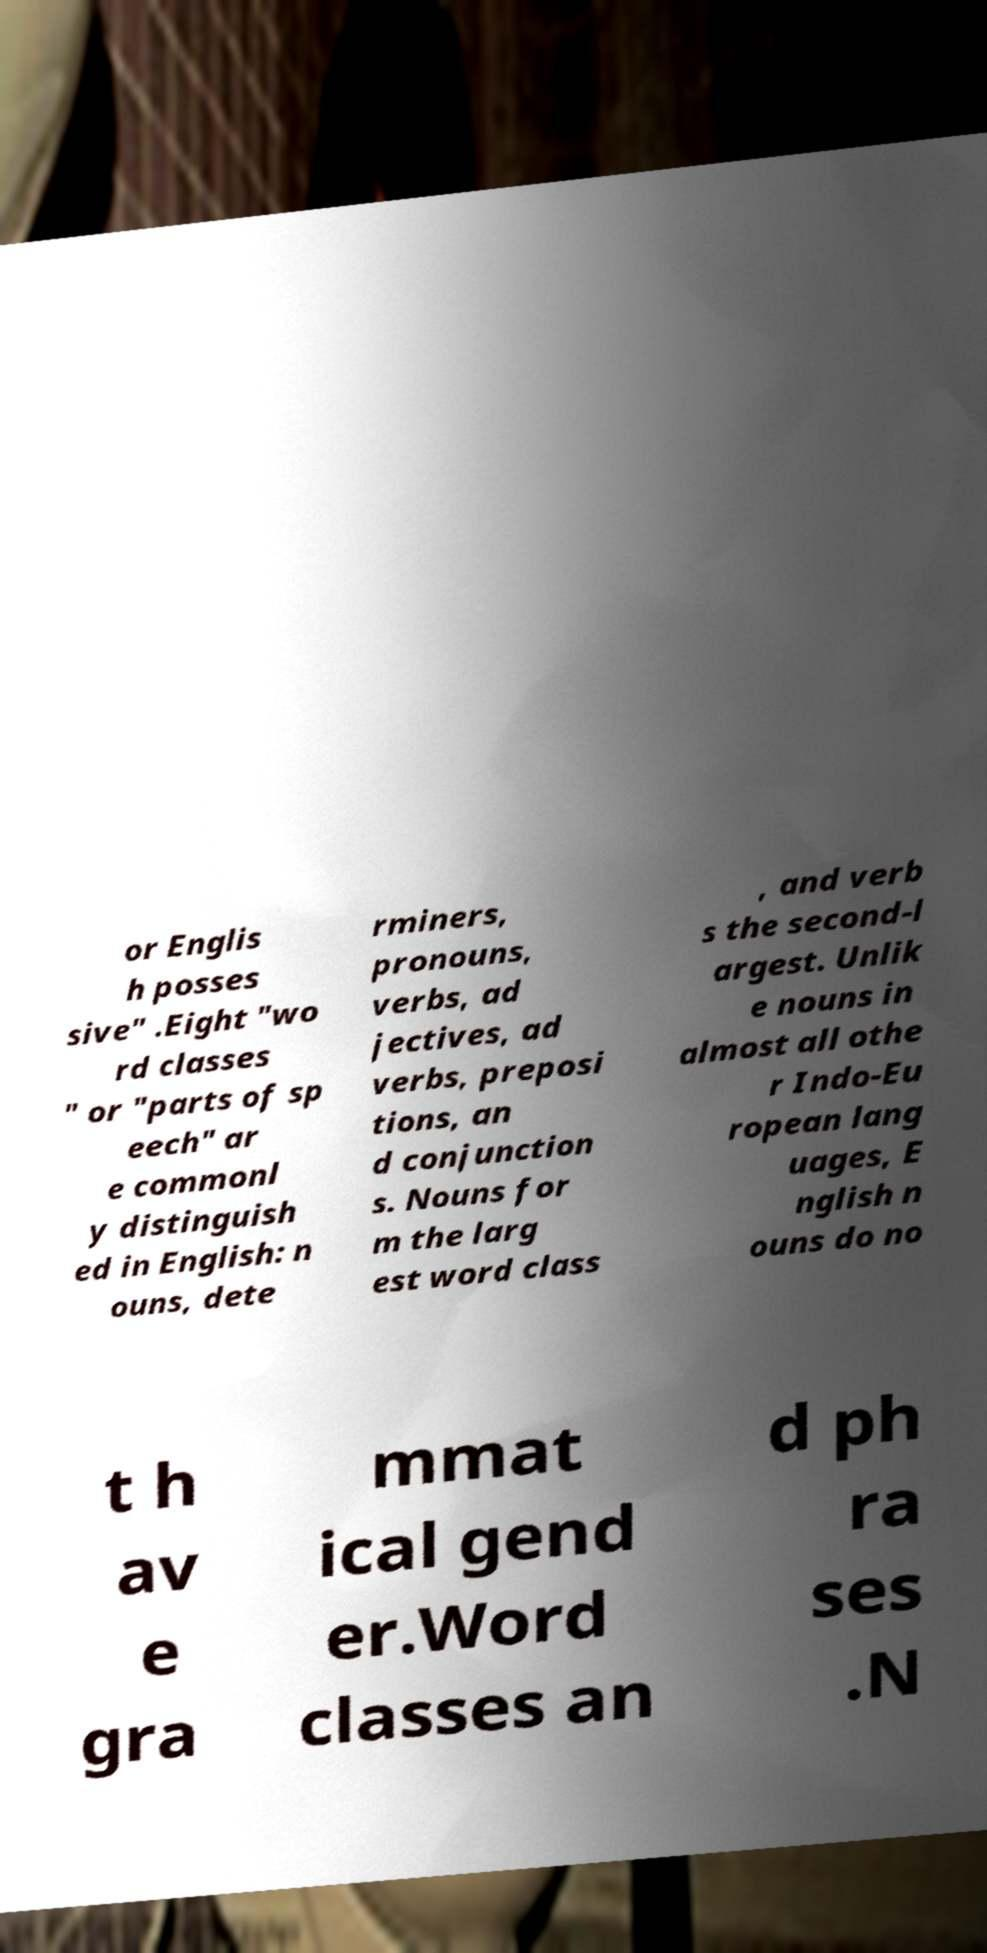What messages or text are displayed in this image? I need them in a readable, typed format. or Englis h posses sive" .Eight "wo rd classes " or "parts of sp eech" ar e commonl y distinguish ed in English: n ouns, dete rminers, pronouns, verbs, ad jectives, ad verbs, preposi tions, an d conjunction s. Nouns for m the larg est word class , and verb s the second-l argest. Unlik e nouns in almost all othe r Indo-Eu ropean lang uages, E nglish n ouns do no t h av e gra mmat ical gend er.Word classes an d ph ra ses .N 